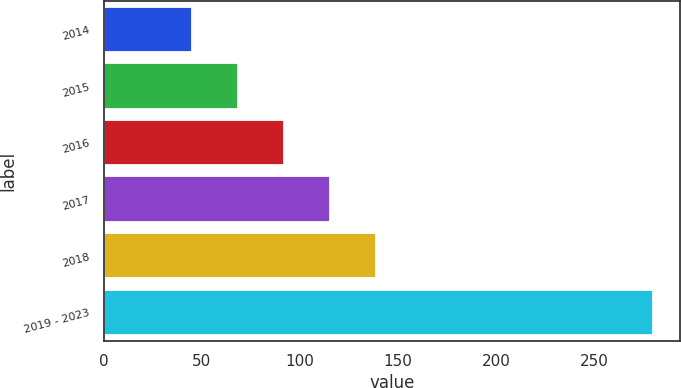Convert chart. <chart><loc_0><loc_0><loc_500><loc_500><bar_chart><fcel>2014<fcel>2015<fcel>2016<fcel>2017<fcel>2018<fcel>2019 - 2023<nl><fcel>45<fcel>68.5<fcel>92<fcel>115.5<fcel>139<fcel>280<nl></chart> 